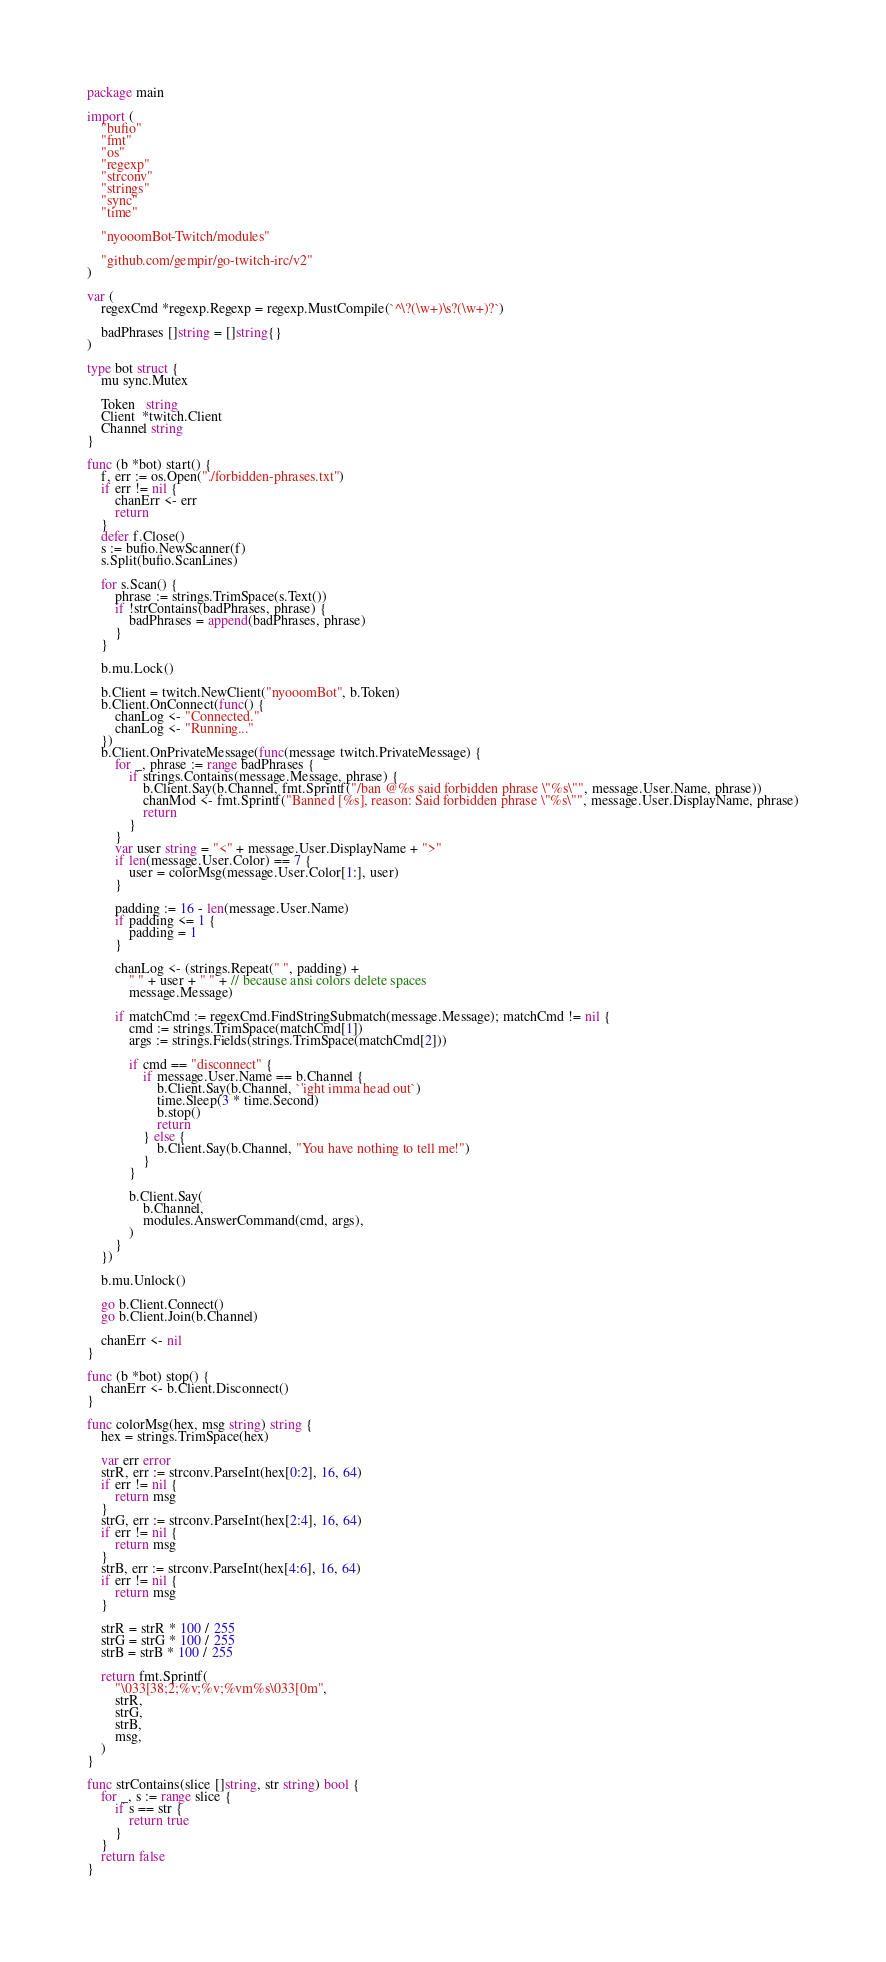Convert code to text. <code><loc_0><loc_0><loc_500><loc_500><_Go_>package main

import (
	"bufio"
	"fmt"
	"os"
	"regexp"
	"strconv"
	"strings"
	"sync"
	"time"

	"nyooomBot-Twitch/modules"

	"github.com/gempir/go-twitch-irc/v2"
)

var (
	regexCmd *regexp.Regexp = regexp.MustCompile(`^\?(\w+)\s?(\w+)?`)

	badPhrases []string = []string{}
)

type bot struct {
	mu sync.Mutex

	Token   string
	Client  *twitch.Client
	Channel string
}

func (b *bot) start() {
	f, err := os.Open("./forbidden-phrases.txt")
	if err != nil {
		chanErr <- err
		return
	}
	defer f.Close()
	s := bufio.NewScanner(f)
	s.Split(bufio.ScanLines)

	for s.Scan() {
		phrase := strings.TrimSpace(s.Text())
		if !strContains(badPhrases, phrase) {
			badPhrases = append(badPhrases, phrase)
		}
	}

	b.mu.Lock()

	b.Client = twitch.NewClient("nyooomBot", b.Token)
	b.Client.OnConnect(func() {
		chanLog <- "Connected."
		chanLog <- "Running..."
	})
	b.Client.OnPrivateMessage(func(message twitch.PrivateMessage) {
		for _, phrase := range badPhrases {
			if strings.Contains(message.Message, phrase) {
				b.Client.Say(b.Channel, fmt.Sprintf("/ban @%s said forbidden phrase \"%s\"", message.User.Name, phrase))
				chanMod <- fmt.Sprintf("Banned [%s], reason: Said forbidden phrase \"%s\"", message.User.DisplayName, phrase)
				return
			}
		}
		var user string = "<" + message.User.DisplayName + ">"
		if len(message.User.Color) == 7 {
			user = colorMsg(message.User.Color[1:], user)
		}

		padding := 16 - len(message.User.Name)
		if padding <= 1 {
			padding = 1
		}

		chanLog <- (strings.Repeat(" ", padding) +
			" " + user + " " + // because ansi colors delete spaces
			message.Message)

		if matchCmd := regexCmd.FindStringSubmatch(message.Message); matchCmd != nil {
			cmd := strings.TrimSpace(matchCmd[1])
			args := strings.Fields(strings.TrimSpace(matchCmd[2]))

			if cmd == "disconnect" {
				if message.User.Name == b.Channel {
					b.Client.Say(b.Channel, `'ight imma head out`)
					time.Sleep(3 * time.Second)
					b.stop()
					return
				} else {
					b.Client.Say(b.Channel, "You have nothing to tell me!")
				}
			}

			b.Client.Say(
				b.Channel,
				modules.AnswerCommand(cmd, args),
			)
		}
	})

	b.mu.Unlock()

	go b.Client.Connect()
	go b.Client.Join(b.Channel)

	chanErr <- nil
}

func (b *bot) stop() {
	chanErr <- b.Client.Disconnect()
}

func colorMsg(hex, msg string) string {
	hex = strings.TrimSpace(hex)

	var err error
	strR, err := strconv.ParseInt(hex[0:2], 16, 64)
	if err != nil {
		return msg
	}
	strG, err := strconv.ParseInt(hex[2:4], 16, 64)
	if err != nil {
		return msg
	}
	strB, err := strconv.ParseInt(hex[4:6], 16, 64)
	if err != nil {
		return msg
	}

	strR = strR * 100 / 255
	strG = strG * 100 / 255
	strB = strB * 100 / 255

	return fmt.Sprintf(
		"\033[38;2;%v;%v;%vm%s\033[0m",
		strR,
		strG,
		strB,
		msg,
	)
}

func strContains(slice []string, str string) bool {
	for _, s := range slice {
		if s == str {
			return true
		}
	}
	return false
}
</code> 